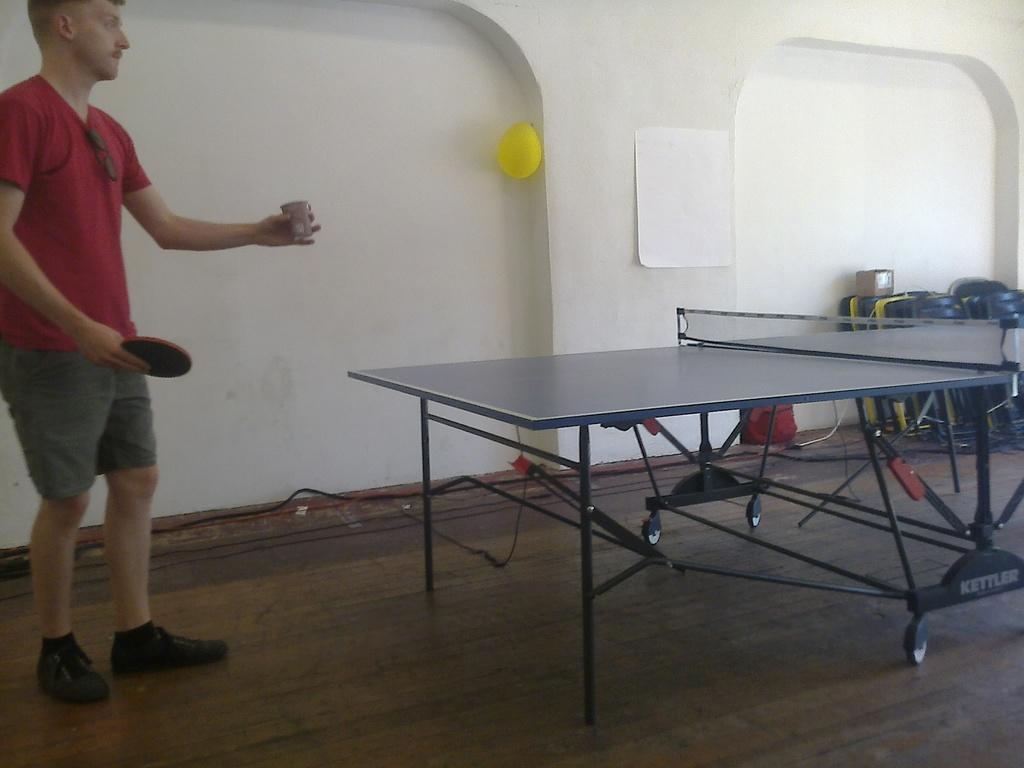Describe this image in one or two sentences. In this image we can see a table tennis. On the left there is a man standing and holding a bat. In the background there is a wall and we can see a paper and a balloon placed on the wall. We can see chairs. 